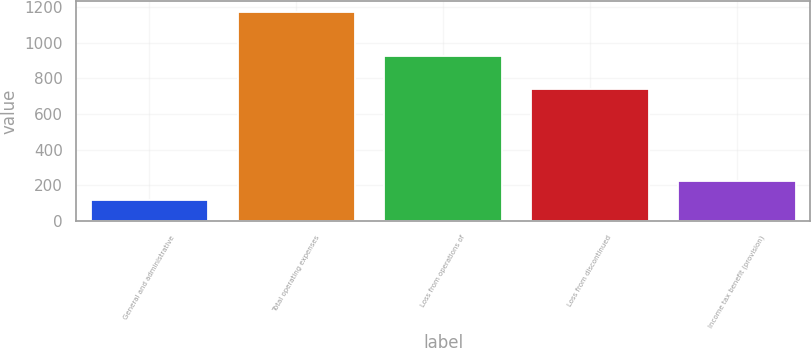Convert chart. <chart><loc_0><loc_0><loc_500><loc_500><bar_chart><fcel>General and administrative<fcel>Total operating expenses<fcel>Loss from operations of<fcel>Loss from discontinued<fcel>Income tax benefit (provision)<nl><fcel>118<fcel>1172<fcel>922<fcel>738<fcel>223.4<nl></chart> 